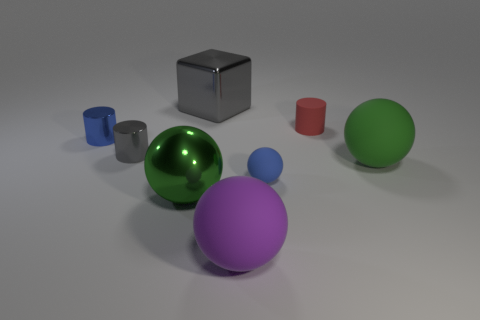Subtract all big green shiny spheres. How many spheres are left? 3 Subtract all green cylinders. How many green spheres are left? 2 Subtract 2 balls. How many balls are left? 2 Add 1 purple metal things. How many objects exist? 9 Subtract all blue spheres. How many spheres are left? 3 Subtract all cylinders. How many objects are left? 5 Subtract all purple cylinders. Subtract all red blocks. How many cylinders are left? 3 Add 1 blue matte balls. How many blue matte balls are left? 2 Add 2 big gray objects. How many big gray objects exist? 3 Subtract 1 blue cylinders. How many objects are left? 7 